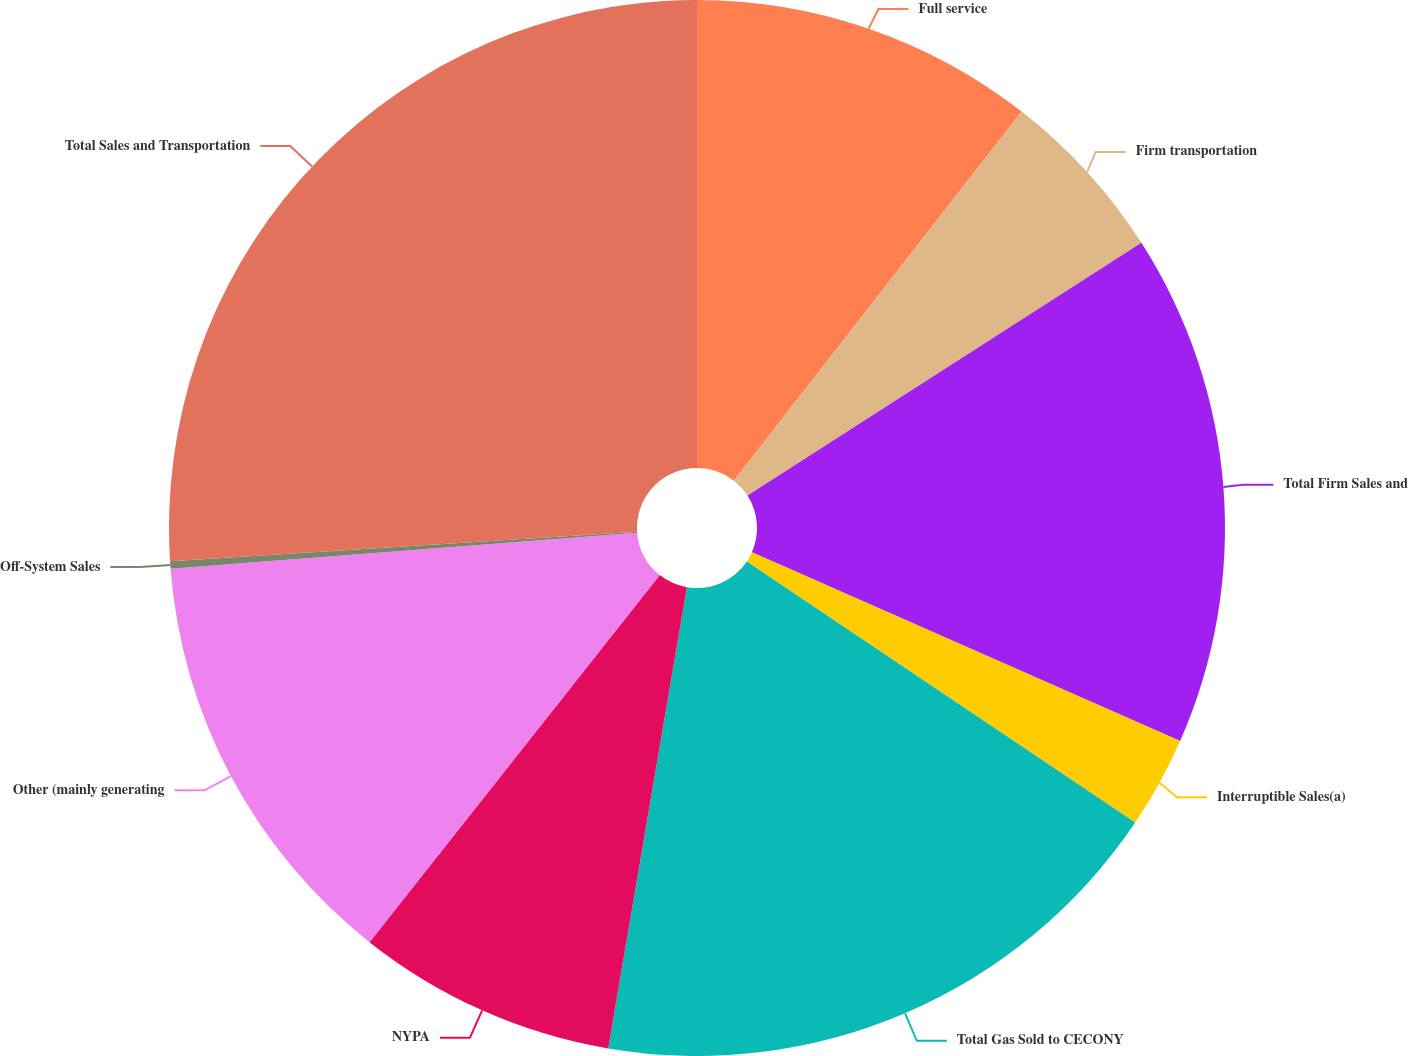Convert chart. <chart><loc_0><loc_0><loc_500><loc_500><pie_chart><fcel>Full service<fcel>Firm transportation<fcel>Total Firm Sales and<fcel>Interruptible Sales(a)<fcel>Total Gas Sold to CECONY<fcel>NYPA<fcel>Other (mainly generating<fcel>Off-System Sales<fcel>Total Sales and Transportation<nl><fcel>10.54%<fcel>5.38%<fcel>15.69%<fcel>2.81%<fcel>18.27%<fcel>7.96%<fcel>13.12%<fcel>0.23%<fcel>26.0%<nl></chart> 